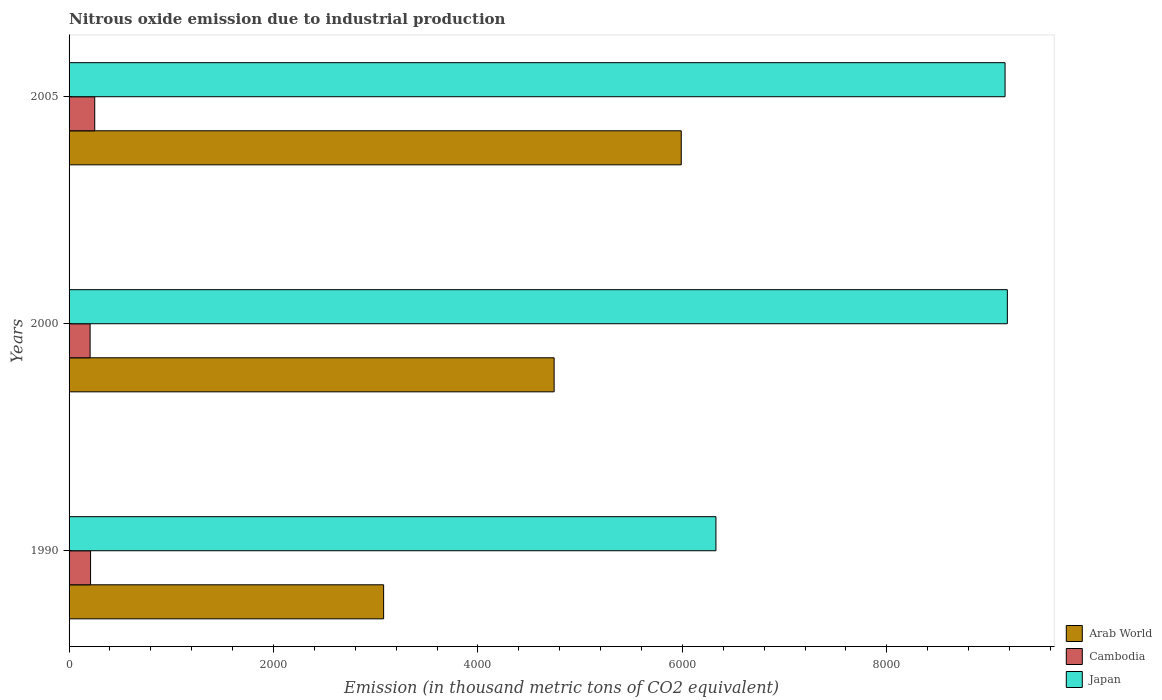How many different coloured bars are there?
Your answer should be very brief. 3. How many groups of bars are there?
Provide a succinct answer. 3. How many bars are there on the 1st tick from the top?
Keep it short and to the point. 3. What is the label of the 2nd group of bars from the top?
Offer a very short reply. 2000. What is the amount of nitrous oxide emitted in Arab World in 2005?
Your answer should be compact. 5989.1. Across all years, what is the maximum amount of nitrous oxide emitted in Cambodia?
Ensure brevity in your answer.  251. Across all years, what is the minimum amount of nitrous oxide emitted in Cambodia?
Your response must be concise. 205.8. In which year was the amount of nitrous oxide emitted in Cambodia minimum?
Provide a succinct answer. 2000. What is the total amount of nitrous oxide emitted in Japan in the graph?
Your answer should be compact. 2.47e+04. What is the difference between the amount of nitrous oxide emitted in Japan in 1990 and that in 2000?
Your answer should be very brief. -2851. What is the difference between the amount of nitrous oxide emitted in Cambodia in 2005 and the amount of nitrous oxide emitted in Japan in 2000?
Give a very brief answer. -8928.4. What is the average amount of nitrous oxide emitted in Cambodia per year?
Your answer should be very brief. 222.33. In the year 2000, what is the difference between the amount of nitrous oxide emitted in Arab World and amount of nitrous oxide emitted in Cambodia?
Make the answer very short. 4539.7. What is the ratio of the amount of nitrous oxide emitted in Cambodia in 1990 to that in 2000?
Your answer should be compact. 1.02. What is the difference between the highest and the second highest amount of nitrous oxide emitted in Arab World?
Offer a very short reply. 1243.6. What is the difference between the highest and the lowest amount of nitrous oxide emitted in Japan?
Offer a very short reply. 2851. Is the sum of the amount of nitrous oxide emitted in Japan in 2000 and 2005 greater than the maximum amount of nitrous oxide emitted in Cambodia across all years?
Provide a short and direct response. Yes. What does the 2nd bar from the top in 1990 represents?
Provide a succinct answer. Cambodia. Is it the case that in every year, the sum of the amount of nitrous oxide emitted in Japan and amount of nitrous oxide emitted in Arab World is greater than the amount of nitrous oxide emitted in Cambodia?
Provide a succinct answer. Yes. How many bars are there?
Give a very brief answer. 9. Are all the bars in the graph horizontal?
Make the answer very short. Yes. What is the difference between two consecutive major ticks on the X-axis?
Offer a terse response. 2000. Does the graph contain any zero values?
Offer a very short reply. No. How many legend labels are there?
Give a very brief answer. 3. How are the legend labels stacked?
Keep it short and to the point. Vertical. What is the title of the graph?
Your answer should be very brief. Nitrous oxide emission due to industrial production. Does "Trinidad and Tobago" appear as one of the legend labels in the graph?
Ensure brevity in your answer.  No. What is the label or title of the X-axis?
Ensure brevity in your answer.  Emission (in thousand metric tons of CO2 equivalent). What is the label or title of the Y-axis?
Offer a very short reply. Years. What is the Emission (in thousand metric tons of CO2 equivalent) in Arab World in 1990?
Ensure brevity in your answer.  3077.4. What is the Emission (in thousand metric tons of CO2 equivalent) in Cambodia in 1990?
Provide a succinct answer. 210.2. What is the Emission (in thousand metric tons of CO2 equivalent) in Japan in 1990?
Keep it short and to the point. 6328.4. What is the Emission (in thousand metric tons of CO2 equivalent) of Arab World in 2000?
Provide a short and direct response. 4745.5. What is the Emission (in thousand metric tons of CO2 equivalent) of Cambodia in 2000?
Provide a succinct answer. 205.8. What is the Emission (in thousand metric tons of CO2 equivalent) in Japan in 2000?
Offer a very short reply. 9179.4. What is the Emission (in thousand metric tons of CO2 equivalent) in Arab World in 2005?
Keep it short and to the point. 5989.1. What is the Emission (in thousand metric tons of CO2 equivalent) in Cambodia in 2005?
Provide a succinct answer. 251. What is the Emission (in thousand metric tons of CO2 equivalent) of Japan in 2005?
Your answer should be very brief. 9157. Across all years, what is the maximum Emission (in thousand metric tons of CO2 equivalent) in Arab World?
Keep it short and to the point. 5989.1. Across all years, what is the maximum Emission (in thousand metric tons of CO2 equivalent) of Cambodia?
Your answer should be very brief. 251. Across all years, what is the maximum Emission (in thousand metric tons of CO2 equivalent) in Japan?
Offer a terse response. 9179.4. Across all years, what is the minimum Emission (in thousand metric tons of CO2 equivalent) in Arab World?
Your response must be concise. 3077.4. Across all years, what is the minimum Emission (in thousand metric tons of CO2 equivalent) in Cambodia?
Give a very brief answer. 205.8. Across all years, what is the minimum Emission (in thousand metric tons of CO2 equivalent) of Japan?
Provide a short and direct response. 6328.4. What is the total Emission (in thousand metric tons of CO2 equivalent) in Arab World in the graph?
Your answer should be compact. 1.38e+04. What is the total Emission (in thousand metric tons of CO2 equivalent) of Cambodia in the graph?
Offer a very short reply. 667. What is the total Emission (in thousand metric tons of CO2 equivalent) in Japan in the graph?
Make the answer very short. 2.47e+04. What is the difference between the Emission (in thousand metric tons of CO2 equivalent) of Arab World in 1990 and that in 2000?
Ensure brevity in your answer.  -1668.1. What is the difference between the Emission (in thousand metric tons of CO2 equivalent) of Japan in 1990 and that in 2000?
Give a very brief answer. -2851. What is the difference between the Emission (in thousand metric tons of CO2 equivalent) in Arab World in 1990 and that in 2005?
Your response must be concise. -2911.7. What is the difference between the Emission (in thousand metric tons of CO2 equivalent) of Cambodia in 1990 and that in 2005?
Offer a terse response. -40.8. What is the difference between the Emission (in thousand metric tons of CO2 equivalent) of Japan in 1990 and that in 2005?
Make the answer very short. -2828.6. What is the difference between the Emission (in thousand metric tons of CO2 equivalent) in Arab World in 2000 and that in 2005?
Your answer should be compact. -1243.6. What is the difference between the Emission (in thousand metric tons of CO2 equivalent) of Cambodia in 2000 and that in 2005?
Provide a short and direct response. -45.2. What is the difference between the Emission (in thousand metric tons of CO2 equivalent) in Japan in 2000 and that in 2005?
Your answer should be very brief. 22.4. What is the difference between the Emission (in thousand metric tons of CO2 equivalent) of Arab World in 1990 and the Emission (in thousand metric tons of CO2 equivalent) of Cambodia in 2000?
Your answer should be compact. 2871.6. What is the difference between the Emission (in thousand metric tons of CO2 equivalent) of Arab World in 1990 and the Emission (in thousand metric tons of CO2 equivalent) of Japan in 2000?
Make the answer very short. -6102. What is the difference between the Emission (in thousand metric tons of CO2 equivalent) in Cambodia in 1990 and the Emission (in thousand metric tons of CO2 equivalent) in Japan in 2000?
Make the answer very short. -8969.2. What is the difference between the Emission (in thousand metric tons of CO2 equivalent) of Arab World in 1990 and the Emission (in thousand metric tons of CO2 equivalent) of Cambodia in 2005?
Provide a succinct answer. 2826.4. What is the difference between the Emission (in thousand metric tons of CO2 equivalent) of Arab World in 1990 and the Emission (in thousand metric tons of CO2 equivalent) of Japan in 2005?
Ensure brevity in your answer.  -6079.6. What is the difference between the Emission (in thousand metric tons of CO2 equivalent) in Cambodia in 1990 and the Emission (in thousand metric tons of CO2 equivalent) in Japan in 2005?
Provide a short and direct response. -8946.8. What is the difference between the Emission (in thousand metric tons of CO2 equivalent) of Arab World in 2000 and the Emission (in thousand metric tons of CO2 equivalent) of Cambodia in 2005?
Your answer should be compact. 4494.5. What is the difference between the Emission (in thousand metric tons of CO2 equivalent) in Arab World in 2000 and the Emission (in thousand metric tons of CO2 equivalent) in Japan in 2005?
Your answer should be very brief. -4411.5. What is the difference between the Emission (in thousand metric tons of CO2 equivalent) of Cambodia in 2000 and the Emission (in thousand metric tons of CO2 equivalent) of Japan in 2005?
Offer a terse response. -8951.2. What is the average Emission (in thousand metric tons of CO2 equivalent) of Arab World per year?
Provide a succinct answer. 4604. What is the average Emission (in thousand metric tons of CO2 equivalent) of Cambodia per year?
Provide a short and direct response. 222.33. What is the average Emission (in thousand metric tons of CO2 equivalent) of Japan per year?
Provide a short and direct response. 8221.6. In the year 1990, what is the difference between the Emission (in thousand metric tons of CO2 equivalent) of Arab World and Emission (in thousand metric tons of CO2 equivalent) of Cambodia?
Your response must be concise. 2867.2. In the year 1990, what is the difference between the Emission (in thousand metric tons of CO2 equivalent) in Arab World and Emission (in thousand metric tons of CO2 equivalent) in Japan?
Offer a terse response. -3251. In the year 1990, what is the difference between the Emission (in thousand metric tons of CO2 equivalent) of Cambodia and Emission (in thousand metric tons of CO2 equivalent) of Japan?
Keep it short and to the point. -6118.2. In the year 2000, what is the difference between the Emission (in thousand metric tons of CO2 equivalent) in Arab World and Emission (in thousand metric tons of CO2 equivalent) in Cambodia?
Keep it short and to the point. 4539.7. In the year 2000, what is the difference between the Emission (in thousand metric tons of CO2 equivalent) of Arab World and Emission (in thousand metric tons of CO2 equivalent) of Japan?
Provide a short and direct response. -4433.9. In the year 2000, what is the difference between the Emission (in thousand metric tons of CO2 equivalent) in Cambodia and Emission (in thousand metric tons of CO2 equivalent) in Japan?
Your response must be concise. -8973.6. In the year 2005, what is the difference between the Emission (in thousand metric tons of CO2 equivalent) of Arab World and Emission (in thousand metric tons of CO2 equivalent) of Cambodia?
Provide a succinct answer. 5738.1. In the year 2005, what is the difference between the Emission (in thousand metric tons of CO2 equivalent) of Arab World and Emission (in thousand metric tons of CO2 equivalent) of Japan?
Make the answer very short. -3167.9. In the year 2005, what is the difference between the Emission (in thousand metric tons of CO2 equivalent) of Cambodia and Emission (in thousand metric tons of CO2 equivalent) of Japan?
Ensure brevity in your answer.  -8906. What is the ratio of the Emission (in thousand metric tons of CO2 equivalent) in Arab World in 1990 to that in 2000?
Ensure brevity in your answer.  0.65. What is the ratio of the Emission (in thousand metric tons of CO2 equivalent) in Cambodia in 1990 to that in 2000?
Offer a terse response. 1.02. What is the ratio of the Emission (in thousand metric tons of CO2 equivalent) of Japan in 1990 to that in 2000?
Offer a terse response. 0.69. What is the ratio of the Emission (in thousand metric tons of CO2 equivalent) in Arab World in 1990 to that in 2005?
Provide a succinct answer. 0.51. What is the ratio of the Emission (in thousand metric tons of CO2 equivalent) of Cambodia in 1990 to that in 2005?
Your answer should be compact. 0.84. What is the ratio of the Emission (in thousand metric tons of CO2 equivalent) of Japan in 1990 to that in 2005?
Ensure brevity in your answer.  0.69. What is the ratio of the Emission (in thousand metric tons of CO2 equivalent) in Arab World in 2000 to that in 2005?
Make the answer very short. 0.79. What is the ratio of the Emission (in thousand metric tons of CO2 equivalent) in Cambodia in 2000 to that in 2005?
Your response must be concise. 0.82. What is the difference between the highest and the second highest Emission (in thousand metric tons of CO2 equivalent) of Arab World?
Keep it short and to the point. 1243.6. What is the difference between the highest and the second highest Emission (in thousand metric tons of CO2 equivalent) of Cambodia?
Provide a succinct answer. 40.8. What is the difference between the highest and the second highest Emission (in thousand metric tons of CO2 equivalent) of Japan?
Make the answer very short. 22.4. What is the difference between the highest and the lowest Emission (in thousand metric tons of CO2 equivalent) in Arab World?
Offer a very short reply. 2911.7. What is the difference between the highest and the lowest Emission (in thousand metric tons of CO2 equivalent) of Cambodia?
Your answer should be very brief. 45.2. What is the difference between the highest and the lowest Emission (in thousand metric tons of CO2 equivalent) in Japan?
Give a very brief answer. 2851. 